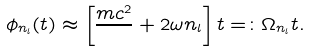Convert formula to latex. <formula><loc_0><loc_0><loc_500><loc_500>\phi _ { n _ { l } } ( t ) \approx \left [ \frac { m c ^ { 2 } } { } + 2 \omega n _ { l } \right ] t = \colon \Omega _ { n _ { l } } t .</formula> 